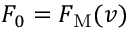<formula> <loc_0><loc_0><loc_500><loc_500>F _ { 0 } = F _ { M } ( v )</formula> 